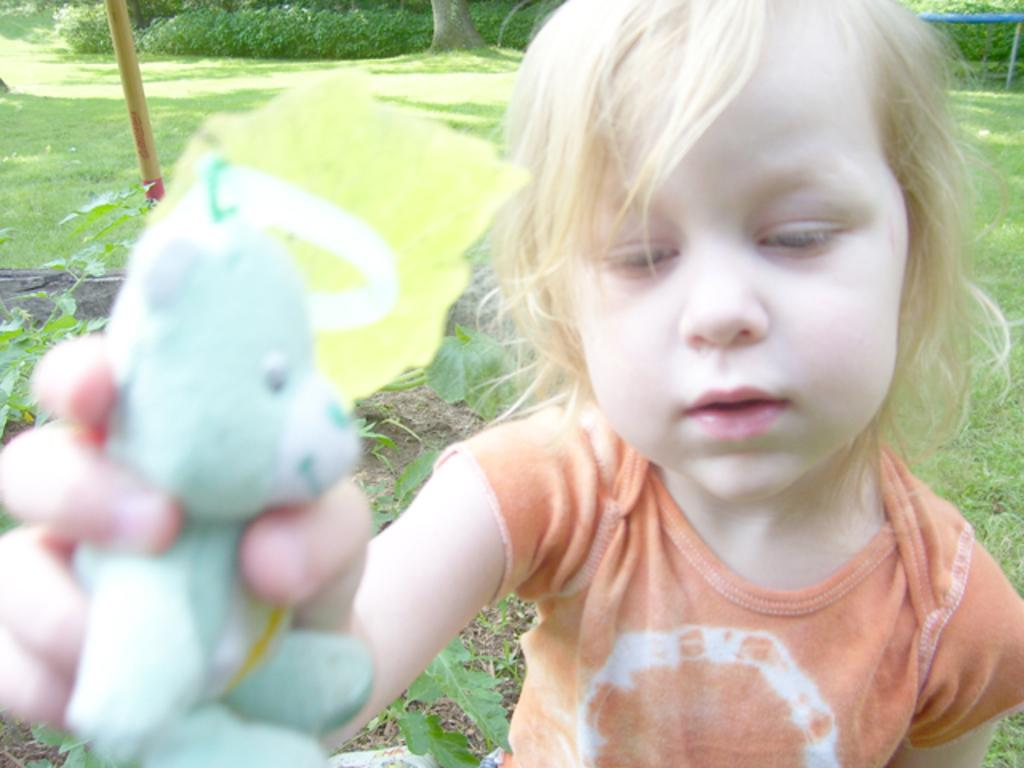What is the main subject of the image? There is a person in the image. What is the person wearing? The person is wearing an orange dress. What is the person holding in the image? The person is holding a blue toy. What type of natural environment can be seen in the image? There are trees and grass in the image. Are there any other objects present in the image besides the person and the toy? Yes, there are other objects present in the image. Can you describe the rainstorm happening in the image? There is no rainstorm present in the image. What type of plane can be seen flying in the image? There is no plane visible in the image. 